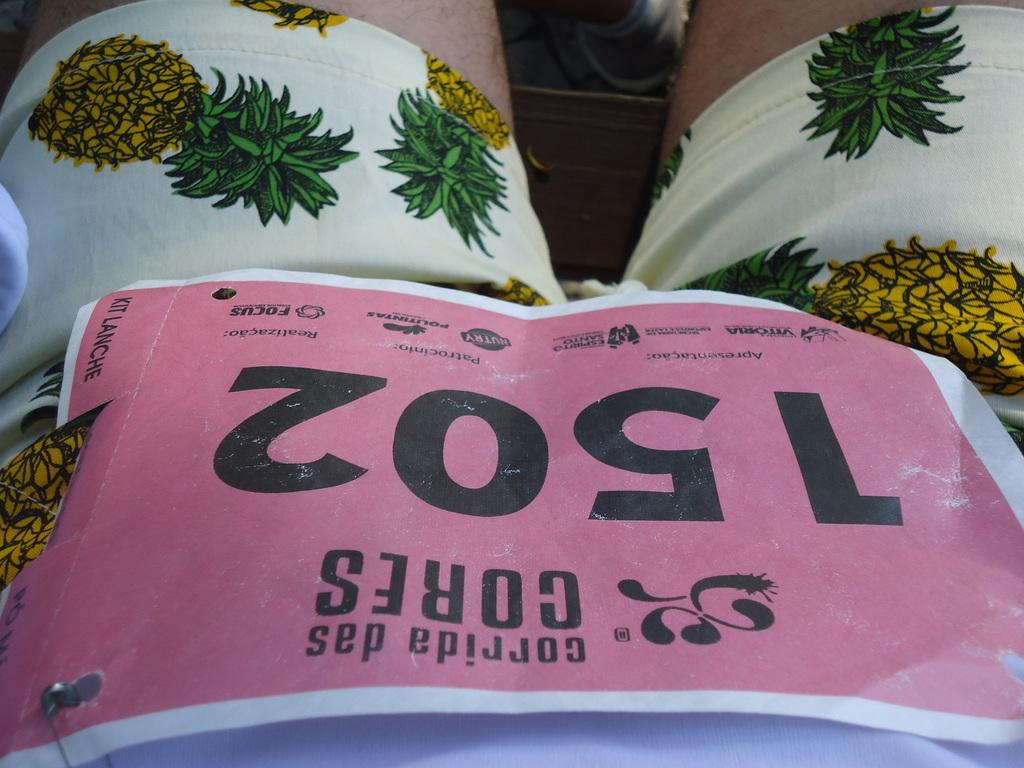What can be seen in the image related to a person? There is a person in the image. What is the person wearing that features pineapple images? The person is wearing a shirt with pineapple images. What is the person doing with the paper? The person has pinned a paper to their dress. What can be found on the paper? There is text written on the paper. What type of accessory is the person wearing around their neck? The person is wearing ties. What is the person's belief about the vessel in the image? There is no vessel present in the image, so it is not possible to discuss the person's belief about it. 